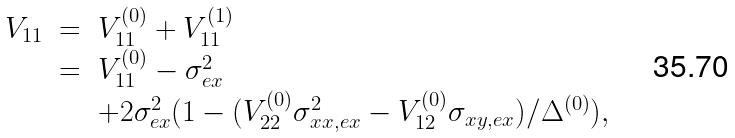<formula> <loc_0><loc_0><loc_500><loc_500>\begin{array} { c c l } V _ { 1 1 } & = & V _ { 1 1 } ^ { ( 0 ) } + V _ { 1 1 } ^ { ( 1 ) } \\ & = & V _ { 1 1 } ^ { ( 0 ) } - \sigma _ { e x } ^ { 2 } \\ & & + 2 \sigma _ { e x } ^ { 2 } ( 1 - ( V _ { 2 2 } ^ { ( 0 ) } \sigma ^ { 2 } _ { x x , e x } - V _ { 1 2 } ^ { ( 0 ) } \sigma _ { x y , e x } ) / \Delta ^ { ( 0 ) } ) , \end{array}</formula> 